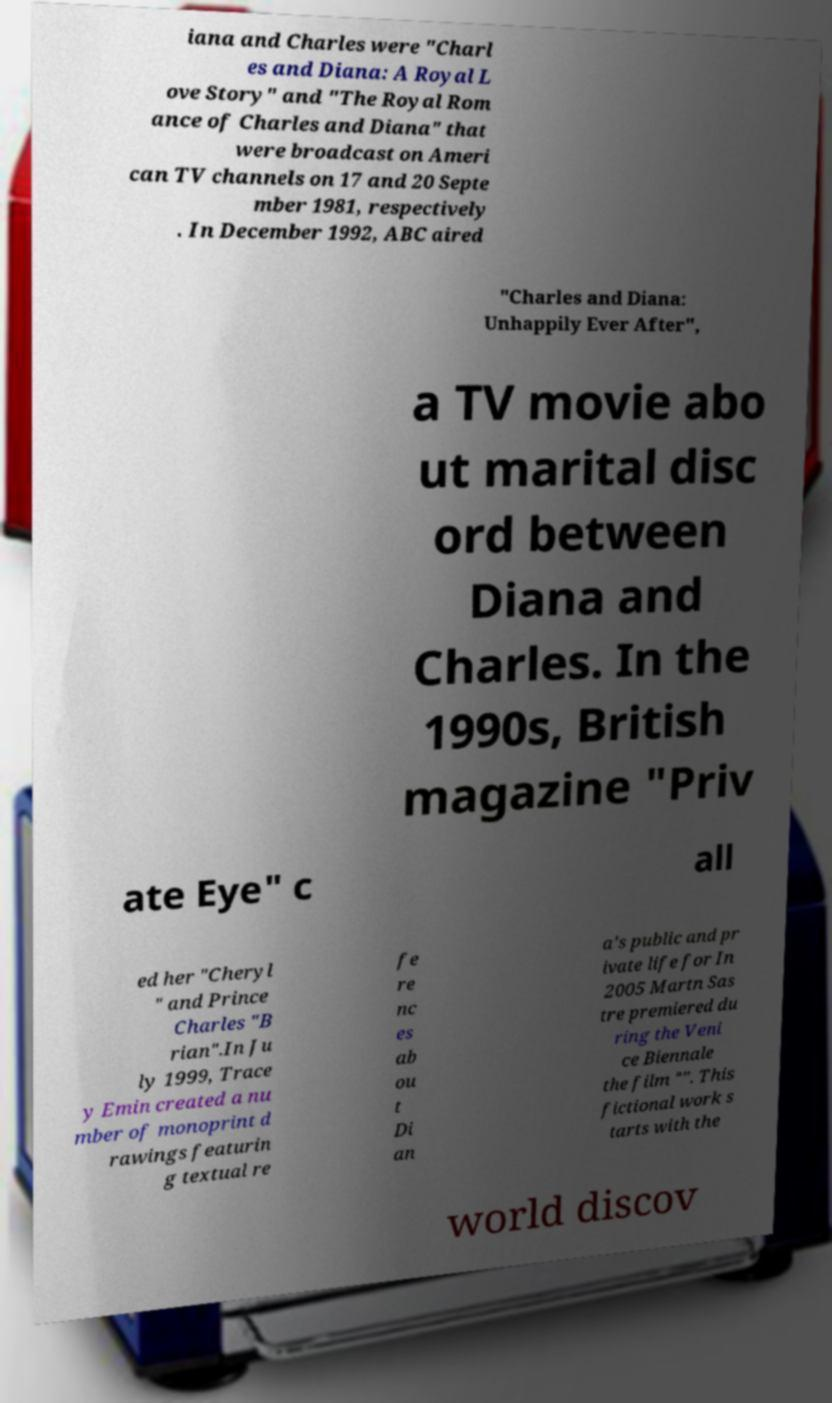There's text embedded in this image that I need extracted. Can you transcribe it verbatim? iana and Charles were "Charl es and Diana: A Royal L ove Story" and "The Royal Rom ance of Charles and Diana" that were broadcast on Ameri can TV channels on 17 and 20 Septe mber 1981, respectively . In December 1992, ABC aired "Charles and Diana: Unhappily Ever After", a TV movie abo ut marital disc ord between Diana and Charles. In the 1990s, British magazine "Priv ate Eye" c all ed her "Cheryl " and Prince Charles "B rian".In Ju ly 1999, Trace y Emin created a nu mber of monoprint d rawings featurin g textual re fe re nc es ab ou t Di an a's public and pr ivate life for In 2005 Martn Sas tre premiered du ring the Veni ce Biennale the film "". This fictional work s tarts with the world discov 